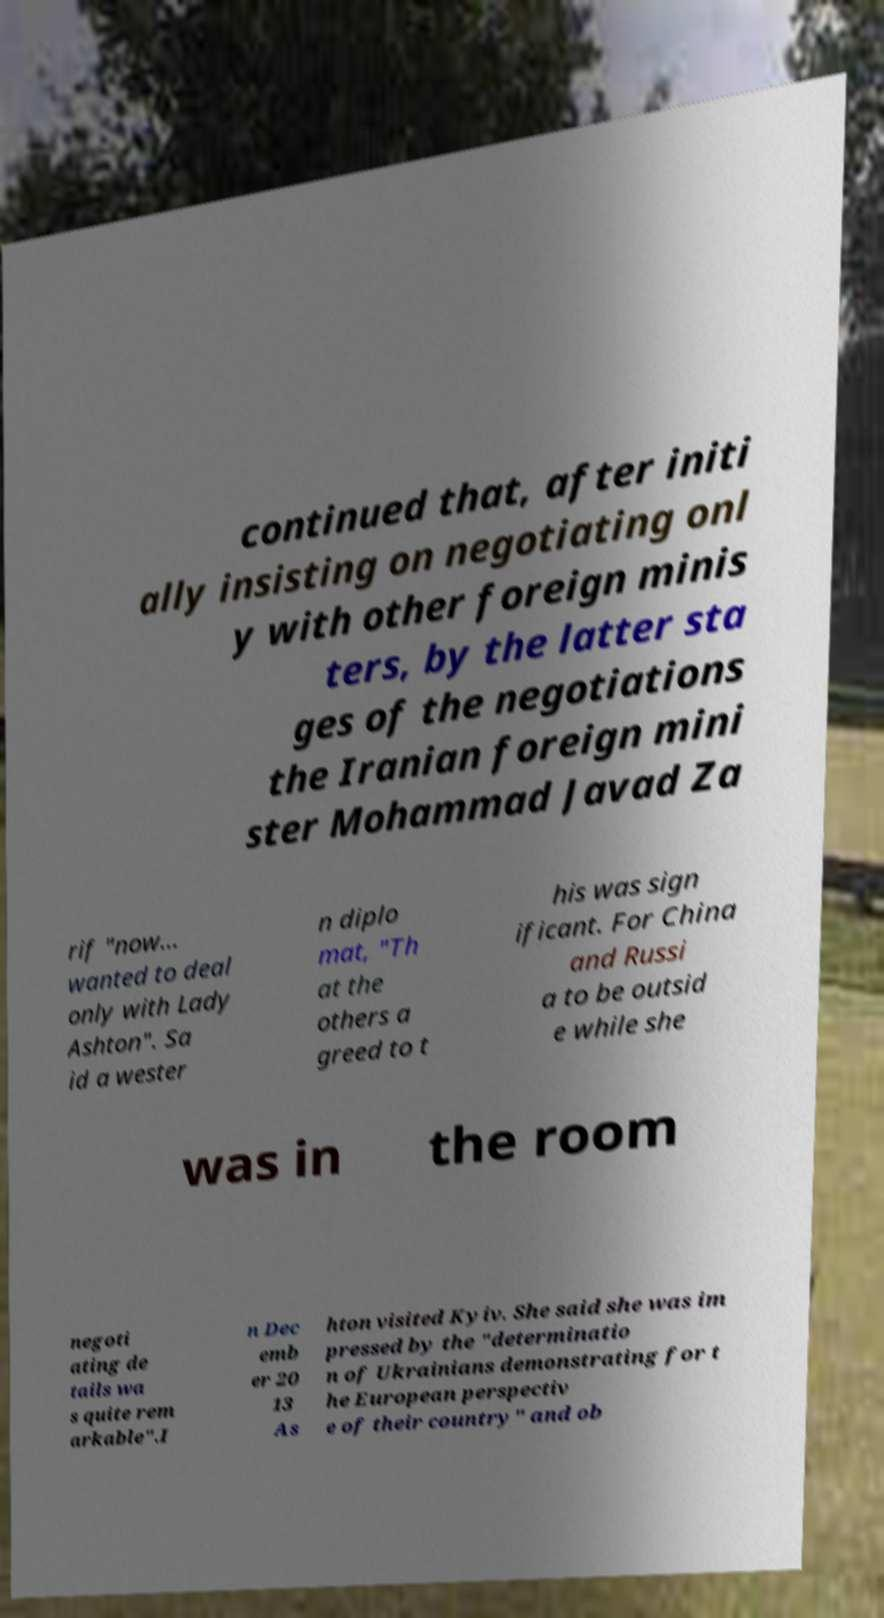There's text embedded in this image that I need extracted. Can you transcribe it verbatim? continued that, after initi ally insisting on negotiating onl y with other foreign minis ters, by the latter sta ges of the negotiations the Iranian foreign mini ster Mohammad Javad Za rif "now... wanted to deal only with Lady Ashton". Sa id a wester n diplo mat, "Th at the others a greed to t his was sign ificant. For China and Russi a to be outsid e while she was in the room negoti ating de tails wa s quite rem arkable".I n Dec emb er 20 13 As hton visited Kyiv. She said she was im pressed by the "determinatio n of Ukrainians demonstrating for t he European perspectiv e of their country" and ob 